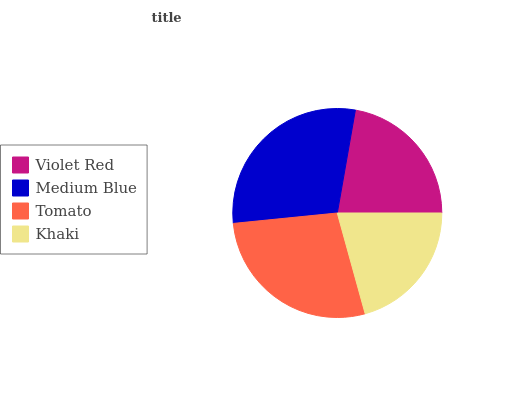Is Khaki the minimum?
Answer yes or no. Yes. Is Medium Blue the maximum?
Answer yes or no. Yes. Is Tomato the minimum?
Answer yes or no. No. Is Tomato the maximum?
Answer yes or no. No. Is Medium Blue greater than Tomato?
Answer yes or no. Yes. Is Tomato less than Medium Blue?
Answer yes or no. Yes. Is Tomato greater than Medium Blue?
Answer yes or no. No. Is Medium Blue less than Tomato?
Answer yes or no. No. Is Tomato the high median?
Answer yes or no. Yes. Is Violet Red the low median?
Answer yes or no. Yes. Is Medium Blue the high median?
Answer yes or no. No. Is Khaki the low median?
Answer yes or no. No. 